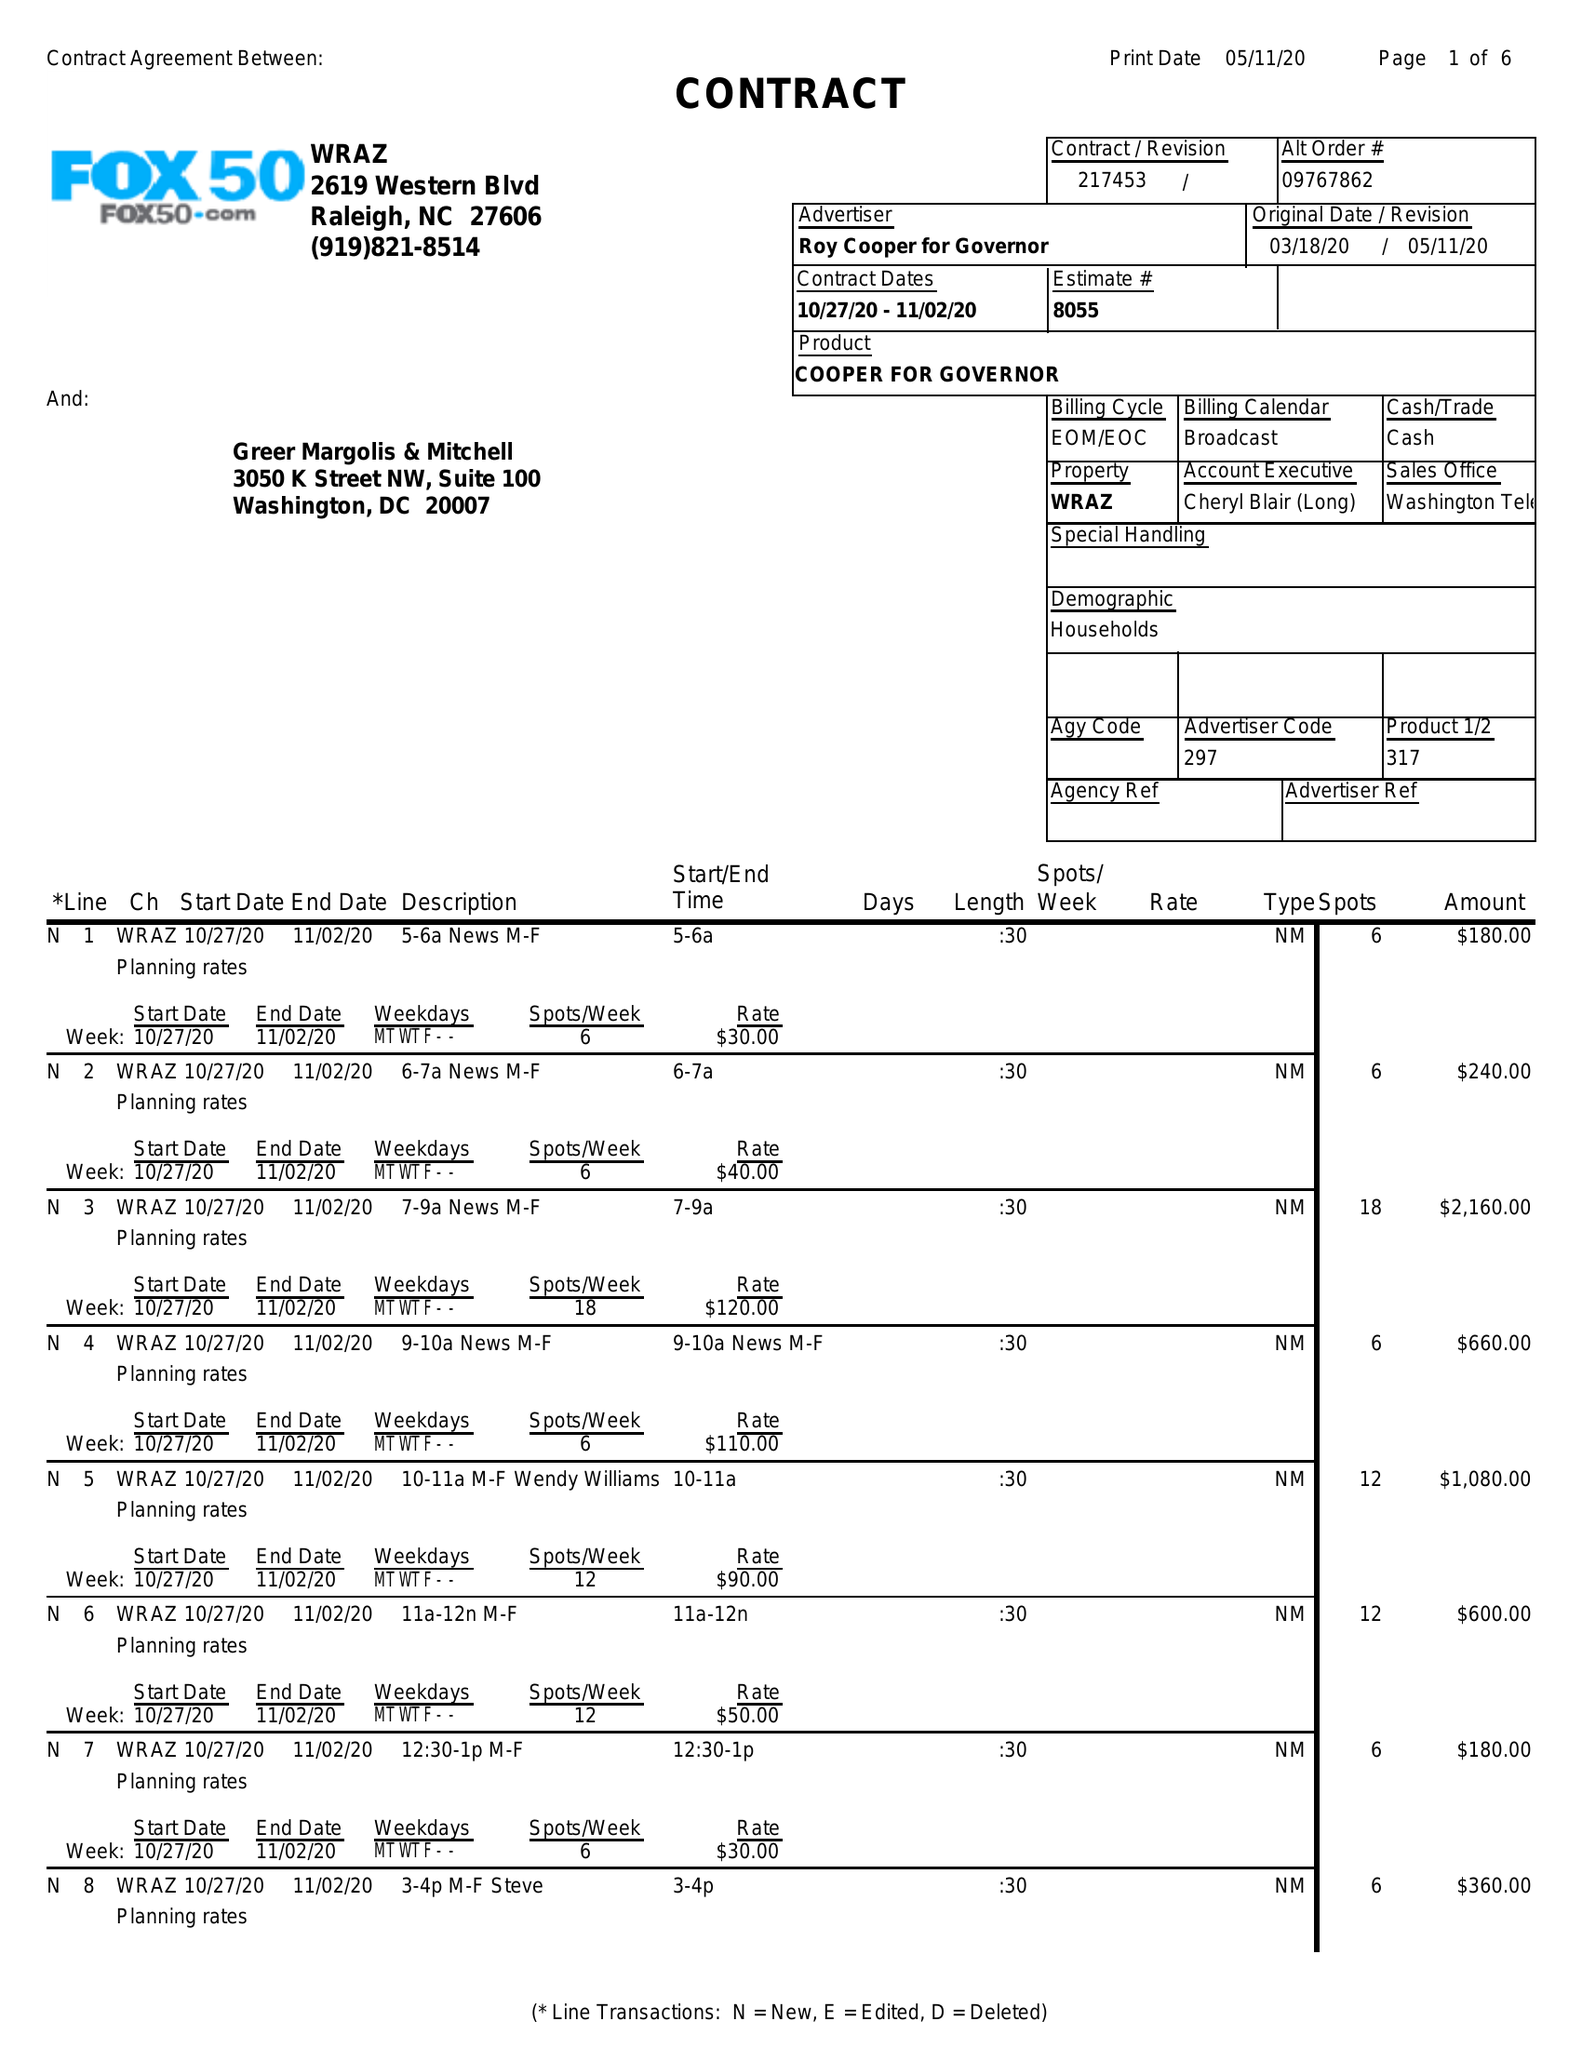What is the value for the advertiser?
Answer the question using a single word or phrase. ROY COOPER FOR GOVERNOR 